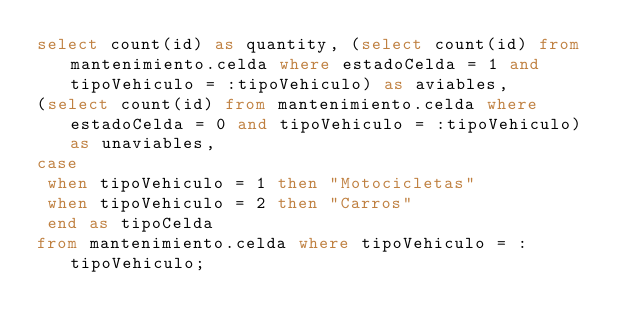Convert code to text. <code><loc_0><loc_0><loc_500><loc_500><_SQL_>select count(id) as quantity, (select count(id) from mantenimiento.celda where estadoCelda = 1 and tipoVehiculo = :tipoVehiculo) as aviables,
(select count(id) from mantenimiento.celda where estadoCelda = 0 and tipoVehiculo = :tipoVehiculo) as unaviables,
case
 when tipoVehiculo = 1 then "Motocicletas"
 when tipoVehiculo = 2 then "Carros"
 end as tipoCelda
from mantenimiento.celda where tipoVehiculo = :tipoVehiculo;</code> 